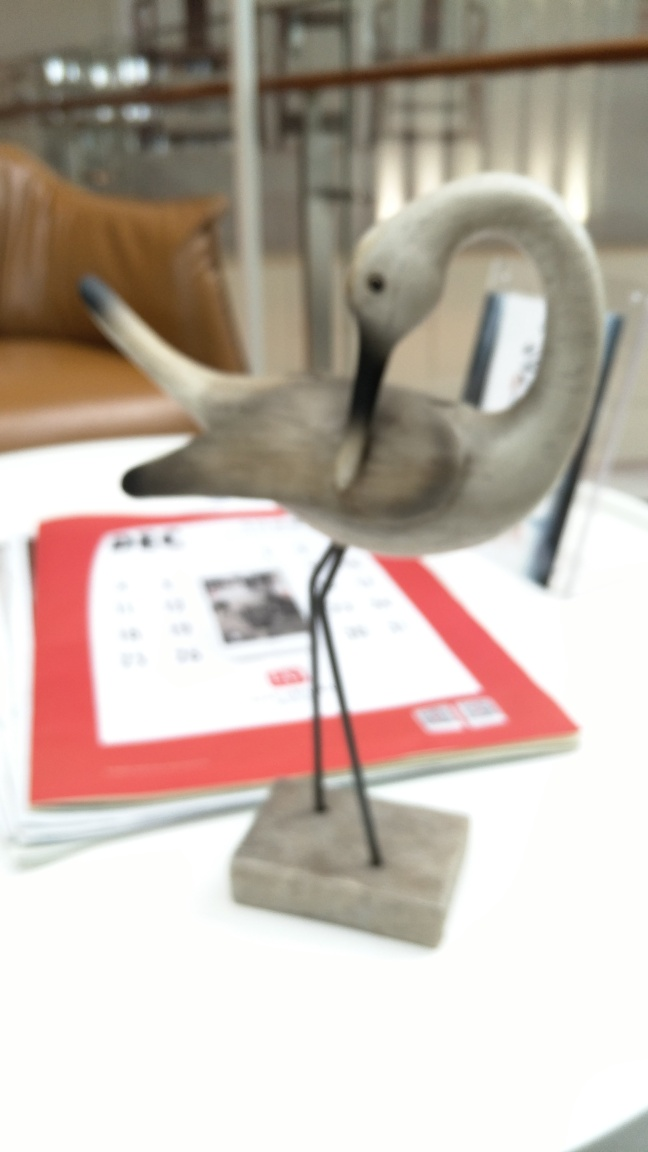Is this crane in an indoor or outdoor setting? The image portrays the crane in an indoor environment; this can be inferred from elements like the tabletop, the chair in the background, and the overall ambiance that suggests an indoor setting. 